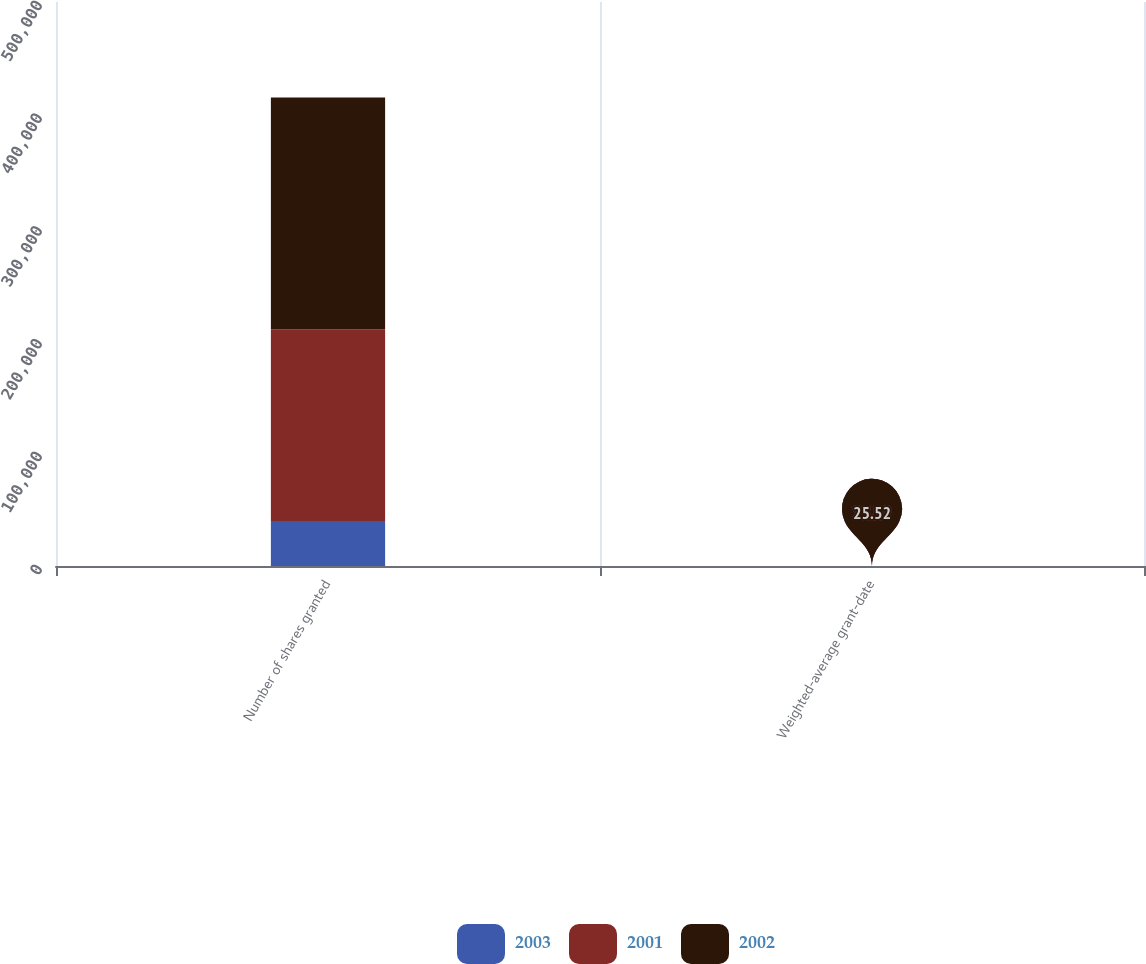<chart> <loc_0><loc_0><loc_500><loc_500><stacked_bar_chart><ecel><fcel>Number of shares granted<fcel>Weighted-average grant-date<nl><fcel>2003<fcel>39960<fcel>25.52<nl><fcel>2001<fcel>170028<fcel>27.84<nl><fcel>2002<fcel>205346<fcel>31.3<nl></chart> 